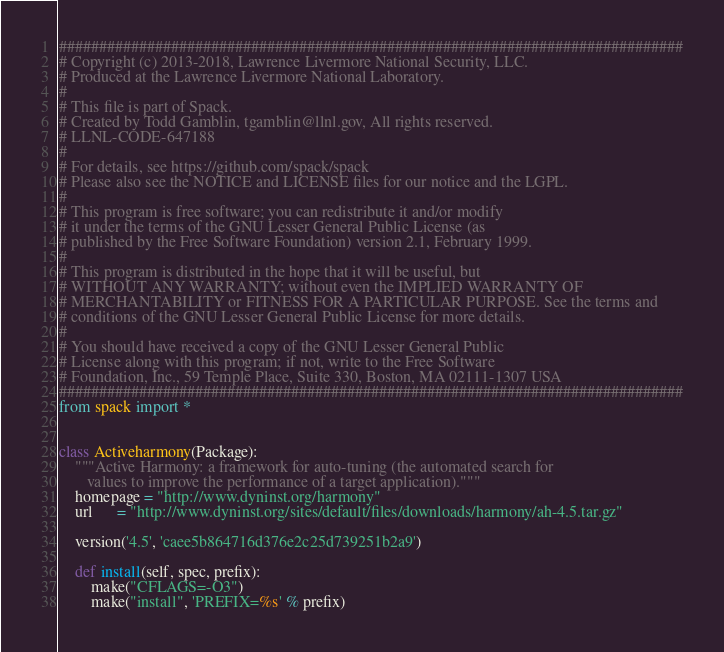Convert code to text. <code><loc_0><loc_0><loc_500><loc_500><_Python_>##############################################################################
# Copyright (c) 2013-2018, Lawrence Livermore National Security, LLC.
# Produced at the Lawrence Livermore National Laboratory.
#
# This file is part of Spack.
# Created by Todd Gamblin, tgamblin@llnl.gov, All rights reserved.
# LLNL-CODE-647188
#
# For details, see https://github.com/spack/spack
# Please also see the NOTICE and LICENSE files for our notice and the LGPL.
#
# This program is free software; you can redistribute it and/or modify
# it under the terms of the GNU Lesser General Public License (as
# published by the Free Software Foundation) version 2.1, February 1999.
#
# This program is distributed in the hope that it will be useful, but
# WITHOUT ANY WARRANTY; without even the IMPLIED WARRANTY OF
# MERCHANTABILITY or FITNESS FOR A PARTICULAR PURPOSE. See the terms and
# conditions of the GNU Lesser General Public License for more details.
#
# You should have received a copy of the GNU Lesser General Public
# License along with this program; if not, write to the Free Software
# Foundation, Inc., 59 Temple Place, Suite 330, Boston, MA 02111-1307 USA
##############################################################################
from spack import *


class Activeharmony(Package):
    """Active Harmony: a framework for auto-tuning (the automated search for
       values to improve the performance of a target application)."""
    homepage = "http://www.dyninst.org/harmony"
    url      = "http://www.dyninst.org/sites/default/files/downloads/harmony/ah-4.5.tar.gz"

    version('4.5', 'caee5b864716d376e2c25d739251b2a9')

    def install(self, spec, prefix):
        make("CFLAGS=-O3")
        make("install", 'PREFIX=%s' % prefix)
</code> 